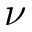Convert formula to latex. <formula><loc_0><loc_0><loc_500><loc_500>\nu</formula> 